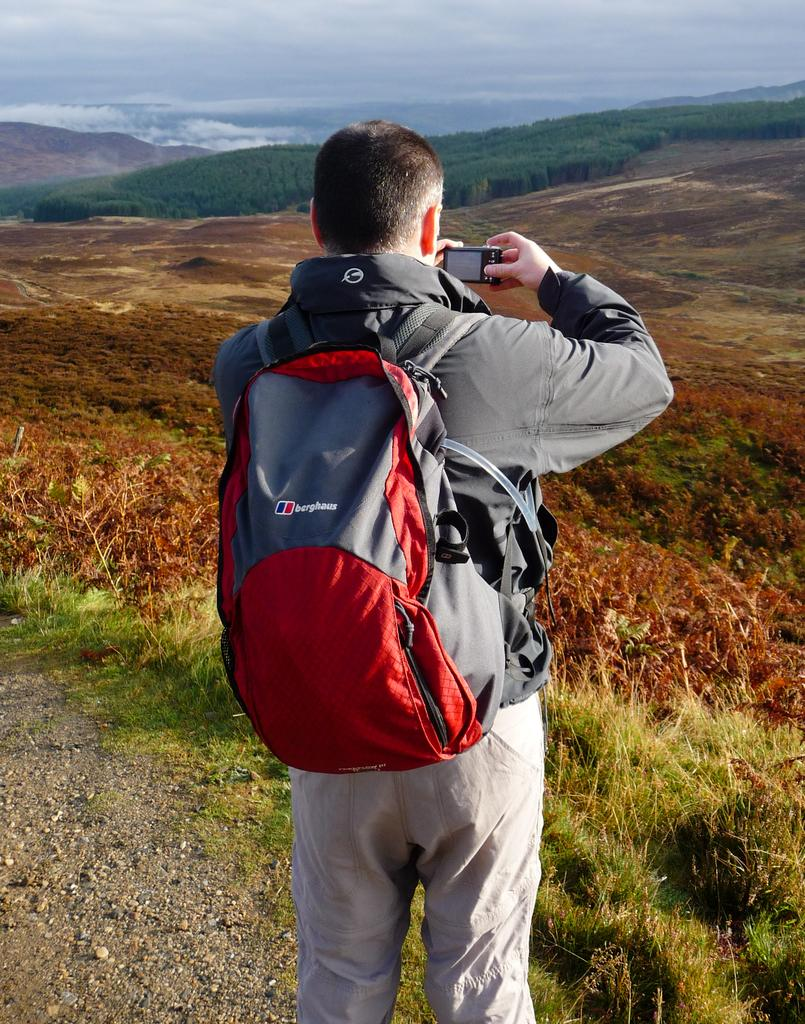<image>
Provide a brief description of the given image. A man with a rucksack reading berghaus takes a photo of a scenic landscape. 